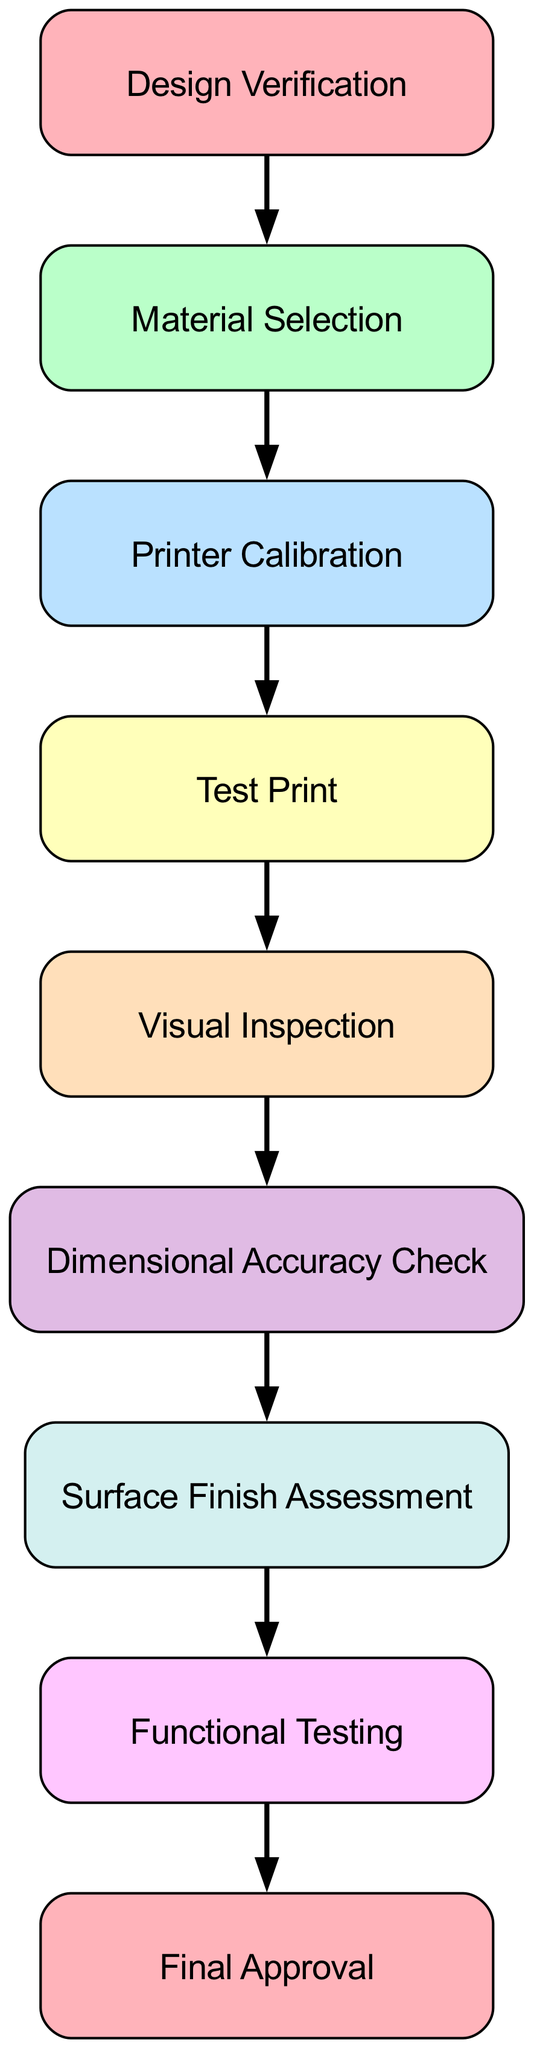What is the first step in the quality control process? The diagram begins with the node labeled "Design Verification," indicating that it is the first step in the quality control process.
Answer: Design Verification How many nodes are present in the diagram? By counting the nodes listed in the diagram, there are a total of nine nodes.
Answer: 9 What follows after "Material Selection"? The flow connects from "Material Selection" to "Printer Calibration," indicating that the next step is printer calibration.
Answer: Printer Calibration Which step assesses dimensional accuracy? The node labeled "Dimensional Accuracy Check" specifically addresses this aspect in the quality control sequence.
Answer: Dimensional Accuracy Check What is the final step in the quality control process? The last node in the sequence is labeled "Final Approval," indicating it is the concluding step of the quality control process.
Answer: Final Approval How many edges connect the nodes in this diagram? By reviewing the edges that illustrate the connections between the nodes, we find there are a total of eight edges in the diagram.
Answer: 8 What step comes before "Functional Testing"? Tracing the flow in the diagram, the step just before "Functional Testing" is "Surface Finish Assessment."
Answer: Surface Finish Assessment What is the relationship between "Visual Inspection" and "Dimensional Accuracy Check"? The diagram indicates that "Visual Inspection" is directly connected to "Dimensional Accuracy Check," meaning "Visual Inspection" is a prerequisite for this check.
Answer: Prerequisite Which steps are involved in the quality control process from the design phase to final approval? The steps include: "Design Verification," "Material Selection," "Printer Calibration," "Test Print," "Visual Inspection," "Dimensional Accuracy Check," "Surface Finish Assessment," "Functional Testing," and culminate in "Final Approval."
Answer: All steps are involved 